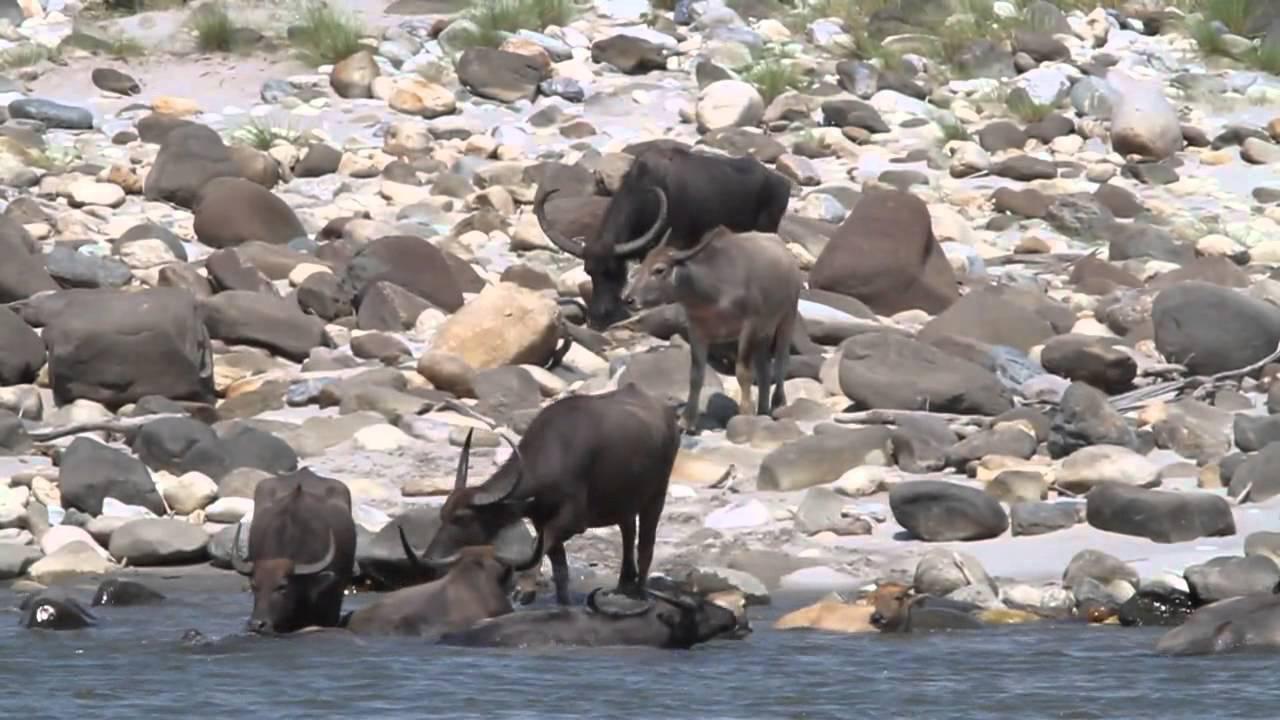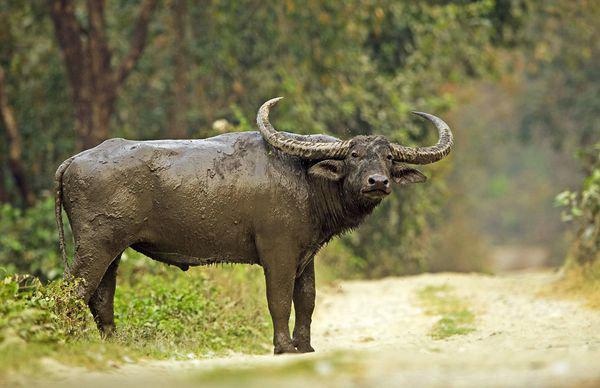The first image is the image on the left, the second image is the image on the right. For the images displayed, is the sentence "At least one of the images contains more than one water buffalo." factually correct? Answer yes or no. Yes. The first image is the image on the left, the second image is the image on the right. Examine the images to the left and right. Is the description "Left image contains one dark water buffalo with light coloring on its lower legs, and its head turned to look directly at the camera." accurate? Answer yes or no. No. 